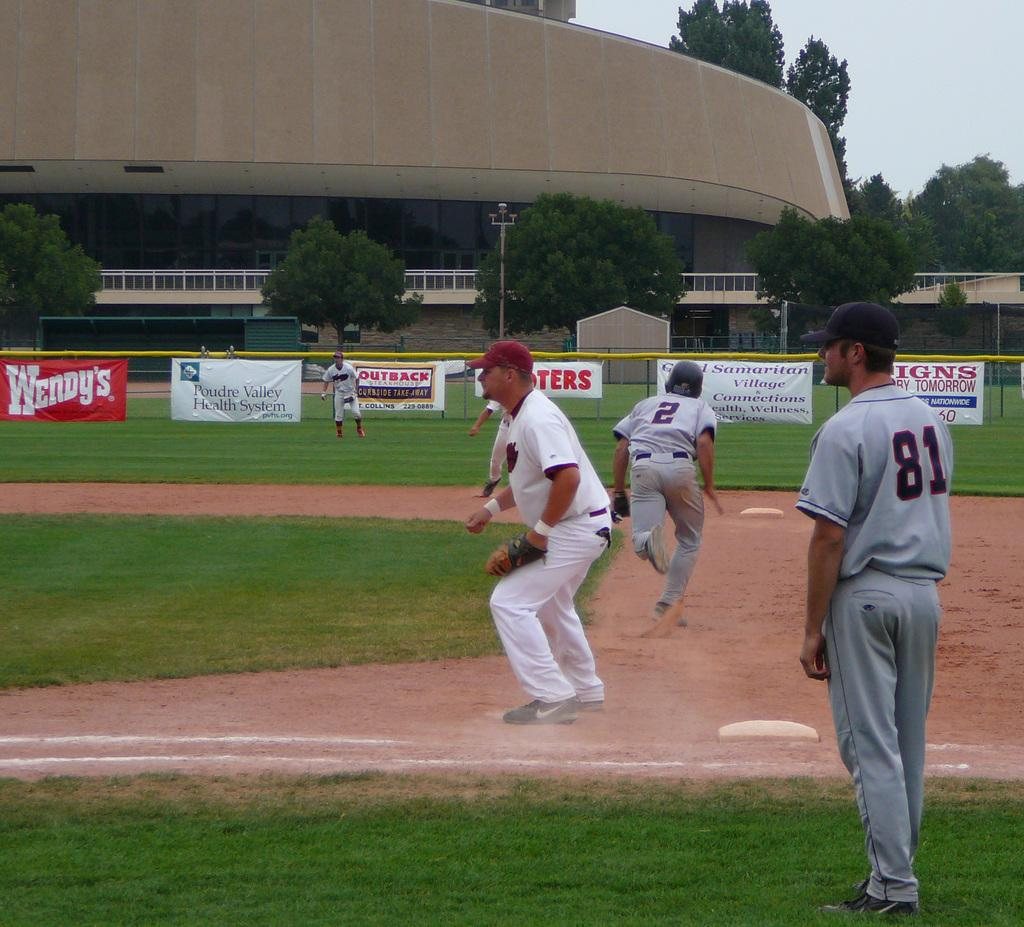<image>
Relay a brief, clear account of the picture shown. Player number 2 in the grey uniform is running to the next base. 